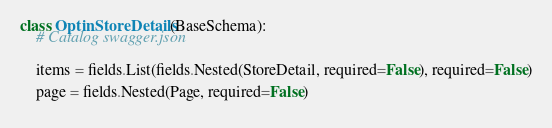<code> <loc_0><loc_0><loc_500><loc_500><_Python_>class OptinStoreDetails(BaseSchema):
    # Catalog swagger.json

    
    items = fields.List(fields.Nested(StoreDetail, required=False), required=False)
    
    page = fields.Nested(Page, required=False)
    

</code> 